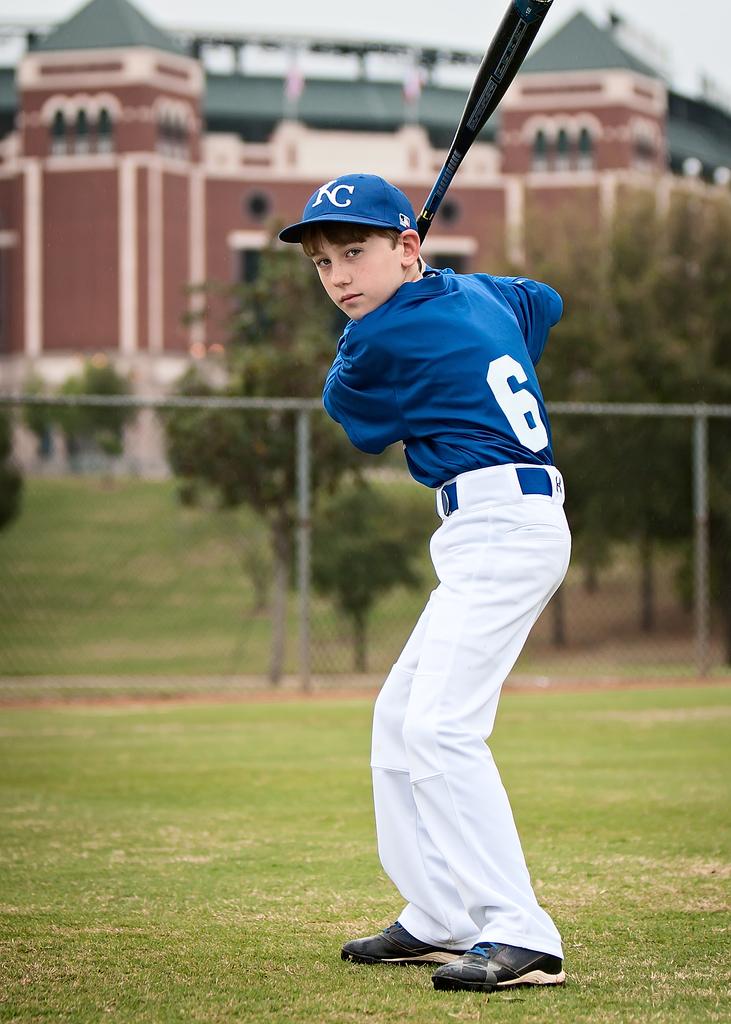What team does he play for?
Provide a succinct answer. Kc. What sport does he play?
Your answer should be very brief. Baseball. 